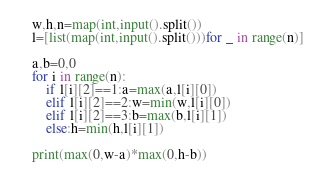<code> <loc_0><loc_0><loc_500><loc_500><_Python_>w,h,n=map(int,input().split())
l=[list(map(int,input().split()))for _ in range(n)]

a,b=0,0
for i in range(n):
    if l[i][2]==1:a=max(a,l[i][0])
    elif l[i][2]==2:w=min(w,l[i][0])
    elif l[i][2]==3:b=max(b,l[i][1])
    else:h=min(h,l[i][1])

print(max(0,w-a)*max(0,h-b))</code> 